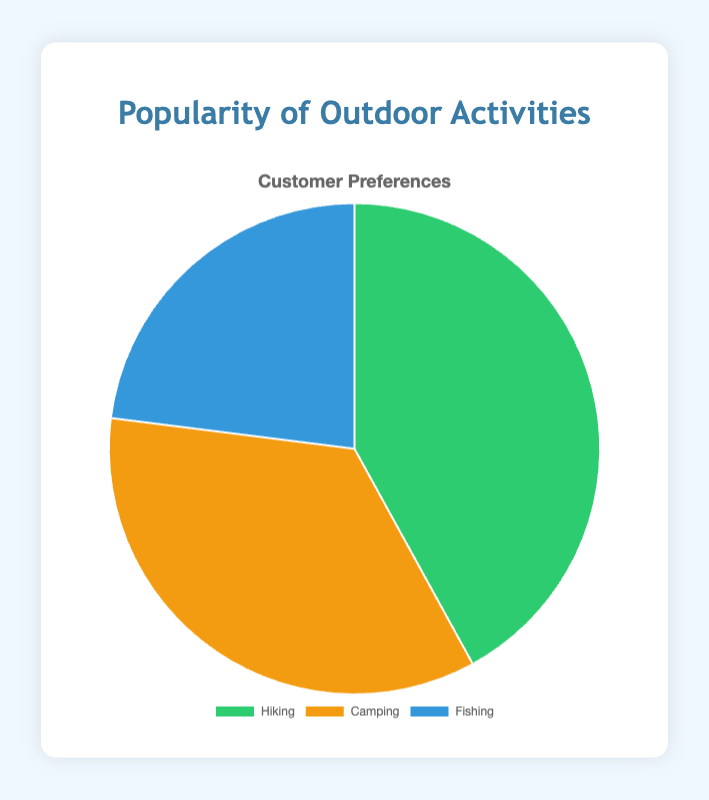What percentage of customers prefer Hiking? From the pie chart, Hiking represents 42 out of the total 100 (42+35+23) parts. The percentage is thus calculated by (42/100) * 100 = 42%.
Answer: 42% Which outdoor activity is the least popular among customers? The visual size of the sections in the pie chart indicates popularity, and the section for Fishing is the smallest.
Answer: Fishing How much more popular is Hiking compared to Fishing? Hiking has 42 parts and Fishing has 23 parts. The difference is calculated by 42 - 23 = 19.
Answer: 19 What is the sum of customers preferring Camping and Fishing? According to the chart, 35 customers prefer Camping and 23 prefer Fishing. Their sum is 35 + 23 = 58.
Answer: 58 If we were to rank the outdoor activities in order of popularity, what would the order be? Evaluating the sizes of the slices, Hiking (42) is highest, followed by Camping (35), and then Fishing (23) being the lowest.
Answer: Hiking, Camping, Fishing What fraction of customers prefer Camping? Out of the total of 100 parts (42+35+23), Camping represents 35 parts. The fraction is thus 35/100 which simplifies to 7/20.
Answer: 7/20 What is the difference in percentage points between Hiking and Camping? Hiking is 42%, and Camping is 35%. The difference between them is calculated by 42 - 35 = 7 percentage points.
Answer: 7 percentage points What is the average number of customers for the three activities? The total number of customers is 42 + 35 + 23 = 100. So the average is 100/3 ≈ 33.33.
Answer: 33.33 What color represents the Hiking section in the pie chart? The Hiking section is represented by the green color segment in the chart.
Answer: Green Is the section representing Camping larger or smaller than the section representing Fishing? From the visual size in the pie chart, the Camping section (35) is larger than the Fishing section (23).
Answer: Larger 